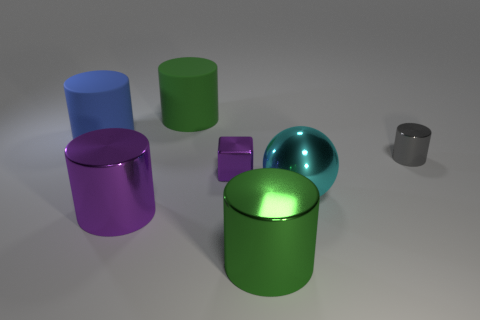There is a green object that is made of the same material as the big ball; what size is it?
Your answer should be compact. Large. What is the color of the matte object that is left of the cylinder behind the big blue object?
Offer a very short reply. Blue. How many cubes have the same material as the cyan object?
Your response must be concise. 1. How many shiny things are either big cylinders or gray cylinders?
Provide a short and direct response. 3. There is a cyan sphere that is the same size as the blue matte cylinder; what material is it?
Your answer should be compact. Metal. Is there a big object made of the same material as the purple cylinder?
Your response must be concise. Yes. There is a tiny metal object to the right of the big cyan object that is to the right of the green cylinder behind the small cylinder; what is its shape?
Make the answer very short. Cylinder. Is the size of the green metal object the same as the green cylinder on the left side of the purple metal block?
Your answer should be very brief. Yes. There is a shiny thing that is both in front of the large cyan object and on the left side of the green metallic thing; what is its shape?
Make the answer very short. Cylinder. How many small things are green cylinders or gray metallic things?
Provide a short and direct response. 1. 